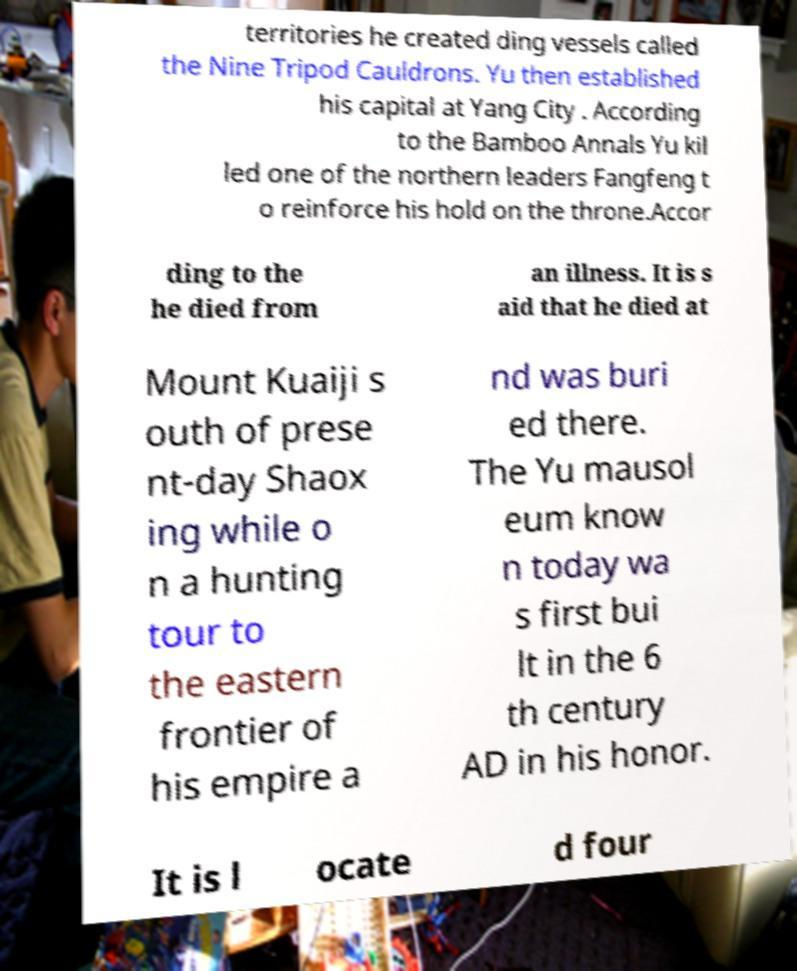There's text embedded in this image that I need extracted. Can you transcribe it verbatim? territories he created ding vessels called the Nine Tripod Cauldrons. Yu then established his capital at Yang City . According to the Bamboo Annals Yu kil led one of the northern leaders Fangfeng t o reinforce his hold on the throne.Accor ding to the he died from an illness. It is s aid that he died at Mount Kuaiji s outh of prese nt-day Shaox ing while o n a hunting tour to the eastern frontier of his empire a nd was buri ed there. The Yu mausol eum know n today wa s first bui lt in the 6 th century AD in his honor. It is l ocate d four 